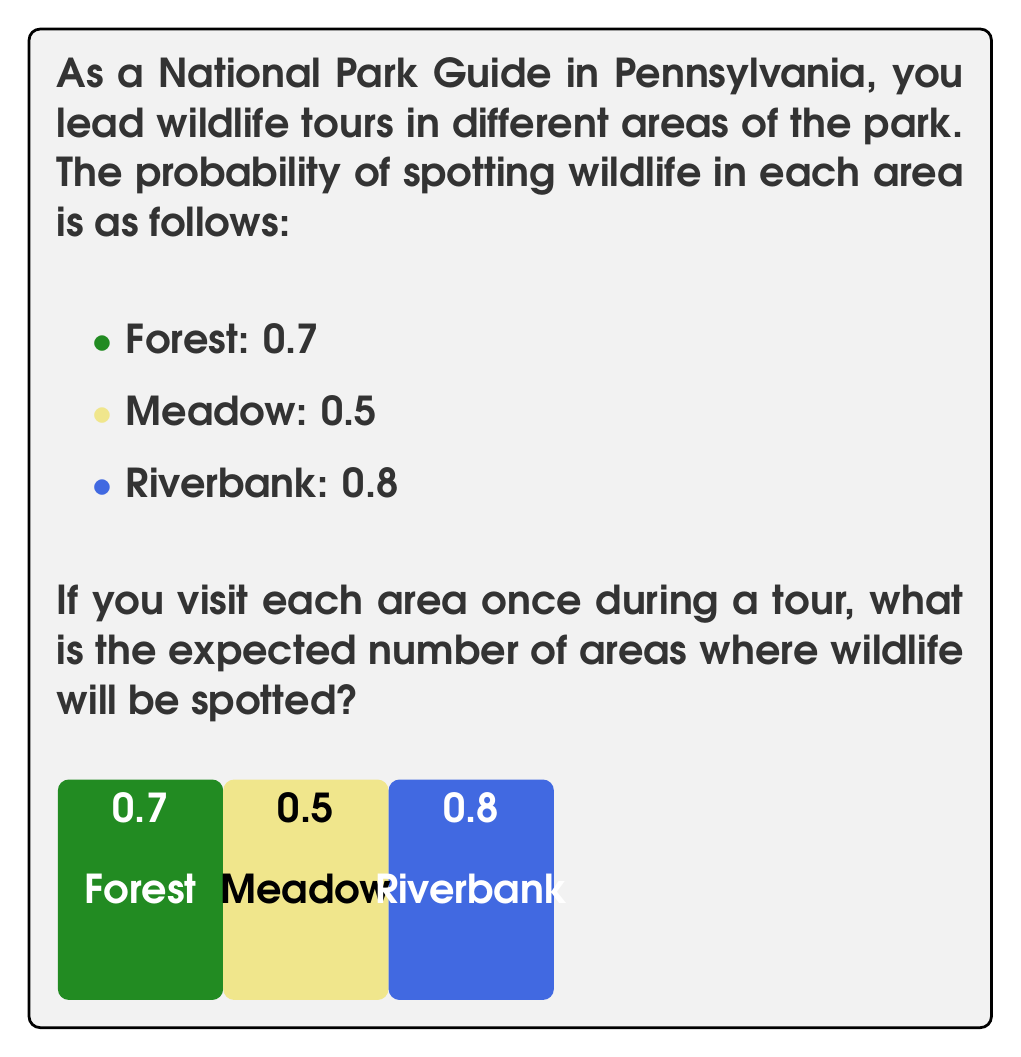Solve this math problem. To solve this problem, we need to use the concept of expected value. The expected value is calculated by multiplying each possible outcome by its probability and then summing these products.

In this case, we have three independent events (spotting wildlife in each area), and we want to find the expected number of successful events.

Let's break it down step by step:

1) For each area, we have two possible outcomes: spotting wildlife (success) or not spotting wildlife (failure).

2) The probability of success for each area is given:
   - Forest: $P(\text{Forest}) = 0.7$
   - Meadow: $P(\text{Meadow}) = 0.5$
   - Riverbank: $P(\text{Riverbank}) = 0.8$

3) For each area, the expected value is equal to its probability of success, because:
   - If wildlife is spotted, it contributes 1 to the count
   - If wildlife is not spotted, it contributes 0 to the count

4) Therefore, the expected value for each area is:
   - Forest: $E(\text{Forest}) = 1 \times 0.7 + 0 \times 0.3 = 0.7$
   - Meadow: $E(\text{Meadow}) = 1 \times 0.5 + 0 \times 0.5 = 0.5$
   - Riverbank: $E(\text{Riverbank}) = 1 \times 0.8 + 0 \times 0.2 = 0.8$

5) The total expected value is the sum of the expected values for each area:

   $$E(\text{Total}) = E(\text{Forest}) + E(\text{Meadow}) + E(\text{Riverbank})$$
   $$E(\text{Total}) = 0.7 + 0.5 + 0.8 = 2$$

Therefore, the expected number of areas where wildlife will be spotted is 2.
Answer: 2 areas 